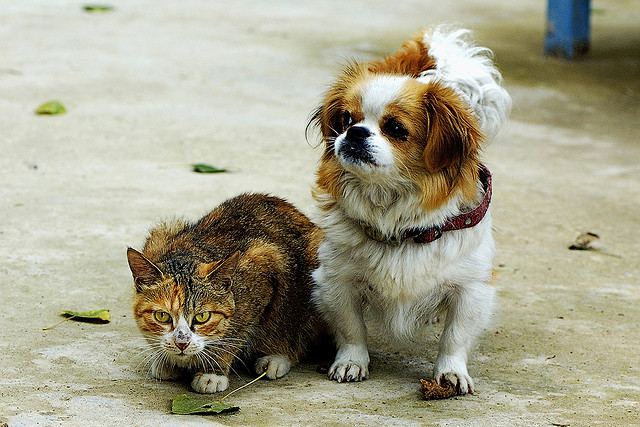<image>What breed of dog is this? I don't know what breed of dog it is. The breed can be long haired chihuahua, shih tzu, king charles spaniel, yorkie or shiatsu. What breed of dog is this? I don't know the breed of the dog. It can be either a long haired chihuahua, shih tzu, king charles spaniel, yorkie, or cavalier king charles spaniel. 